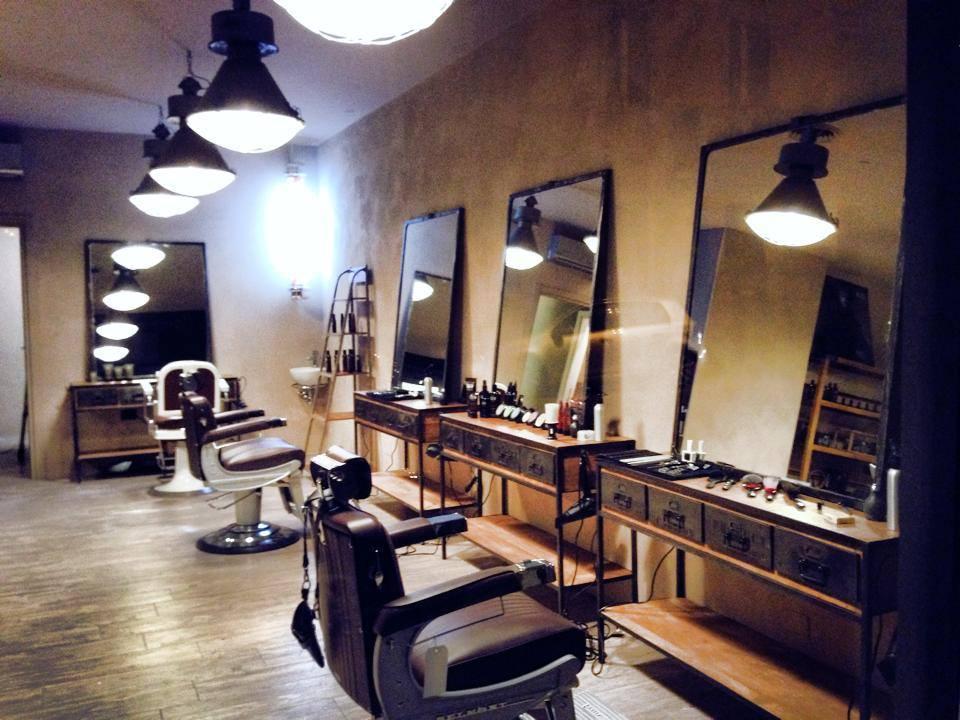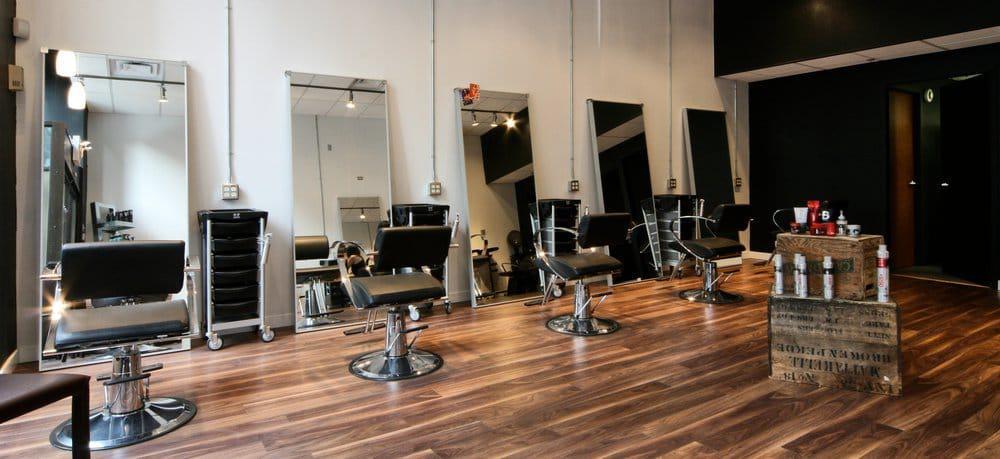The first image is the image on the left, the second image is the image on the right. Analyze the images presented: Is the assertion "An exposed brick wall is shown in exactly one image." valid? Answer yes or no. No. 